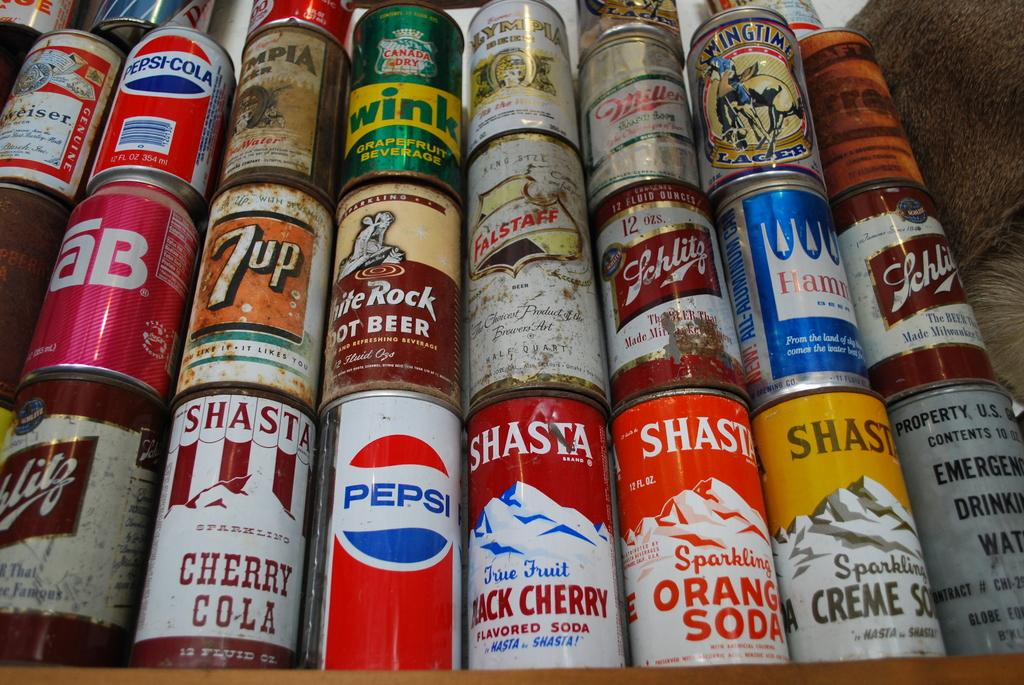<image>
Write a terse but informative summary of the picture. Soda Cans stacked with different companies labeled on them; example is a Pepsi Can. 